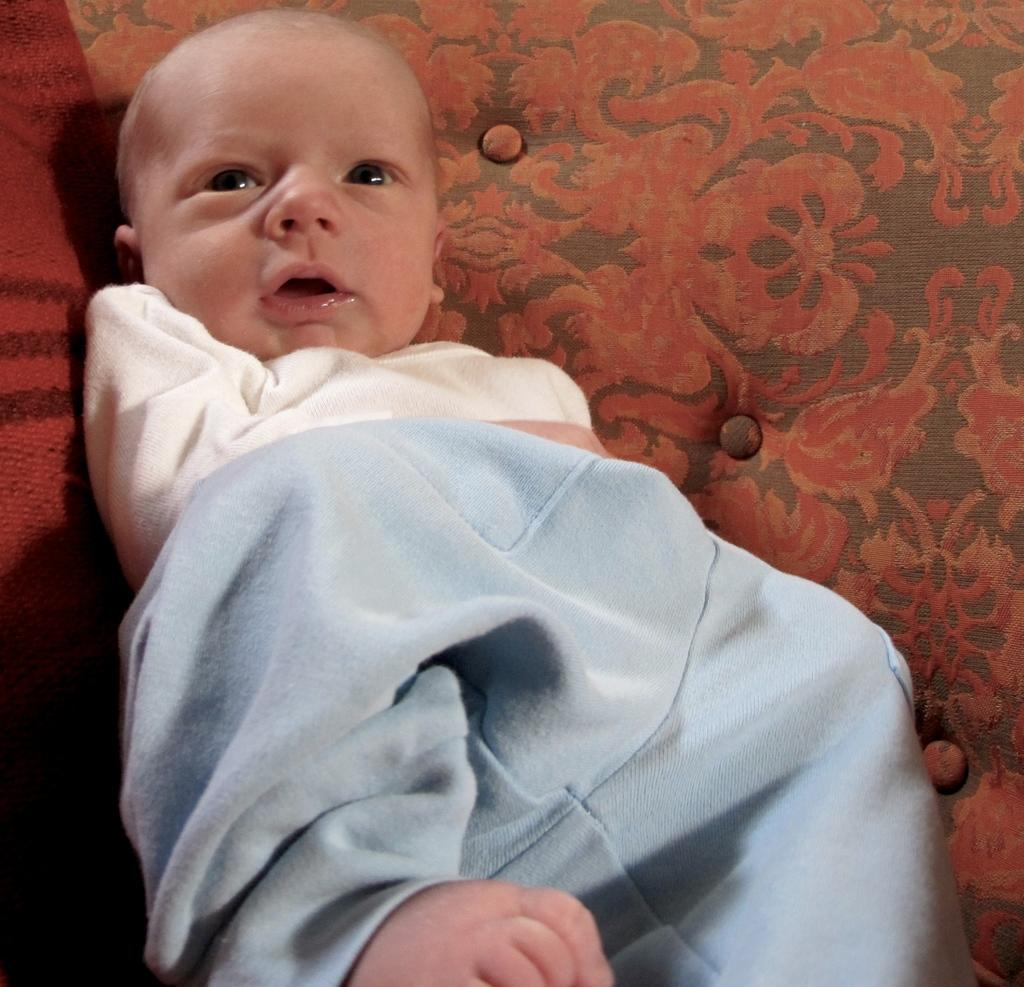What is the main subject of the image? The main subject of the image is a baby. What is the baby wearing in the image? The baby is wearing a white t-shirt. How many jellyfish can be seen swimming in the background of the image? There are no jellyfish present in the image; it features a baby wearing a white t-shirt. What type of rice is being cooked in the image? There is no rice present in the image. 